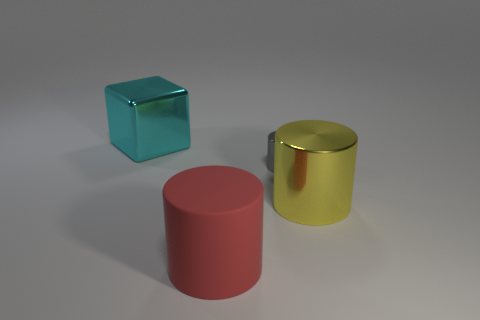Add 3 tiny shiny objects. How many objects exist? 7 Subtract all cylinders. How many objects are left? 1 Add 2 cylinders. How many cylinders exist? 5 Subtract 0 purple cylinders. How many objects are left? 4 Subtract all small gray shiny cylinders. Subtract all large matte objects. How many objects are left? 2 Add 2 small gray cylinders. How many small gray cylinders are left? 3 